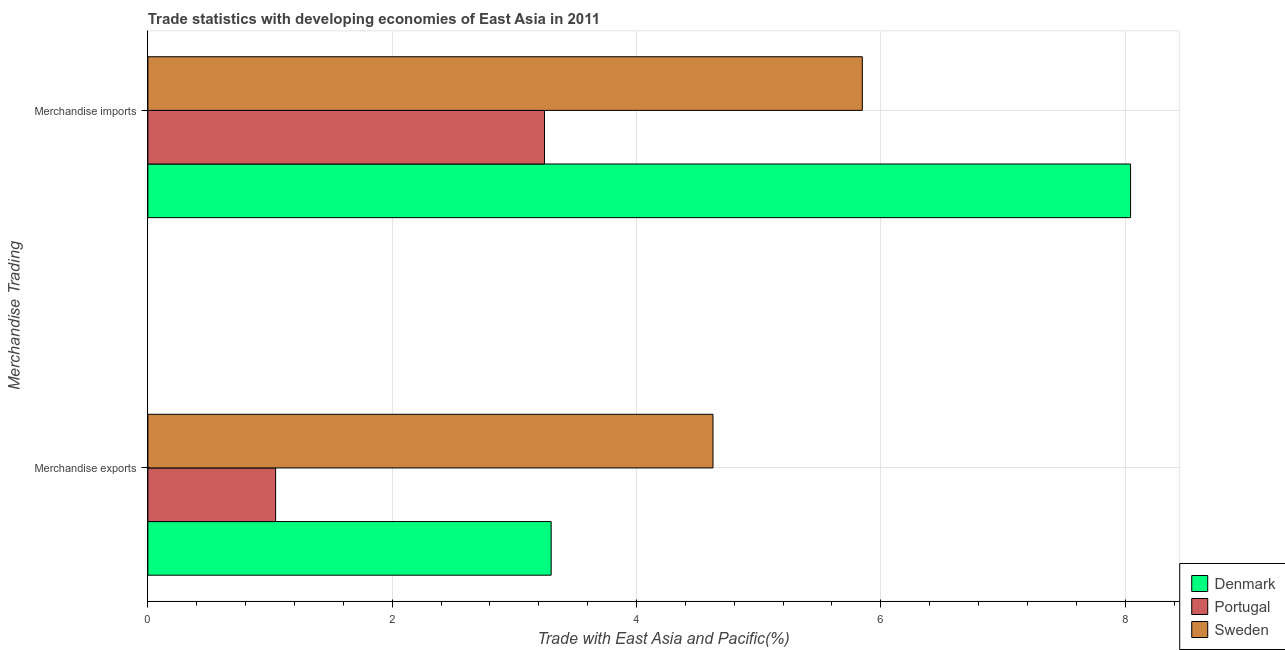Are the number of bars per tick equal to the number of legend labels?
Keep it short and to the point. Yes. Are the number of bars on each tick of the Y-axis equal?
Ensure brevity in your answer.  Yes. How many bars are there on the 2nd tick from the bottom?
Ensure brevity in your answer.  3. What is the merchandise exports in Portugal?
Provide a short and direct response. 1.05. Across all countries, what is the maximum merchandise exports?
Offer a very short reply. 4.63. Across all countries, what is the minimum merchandise exports?
Your answer should be compact. 1.05. In which country was the merchandise exports maximum?
Ensure brevity in your answer.  Sweden. In which country was the merchandise exports minimum?
Give a very brief answer. Portugal. What is the total merchandise exports in the graph?
Ensure brevity in your answer.  8.97. What is the difference between the merchandise imports in Sweden and that in Denmark?
Ensure brevity in your answer.  -2.2. What is the difference between the merchandise exports in Denmark and the merchandise imports in Sweden?
Give a very brief answer. -2.55. What is the average merchandise exports per country?
Provide a succinct answer. 2.99. What is the difference between the merchandise imports and merchandise exports in Portugal?
Your response must be concise. 2.2. In how many countries, is the merchandise exports greater than 3.2 %?
Provide a succinct answer. 2. What is the ratio of the merchandise exports in Denmark to that in Portugal?
Keep it short and to the point. 3.16. Is the merchandise exports in Sweden less than that in Denmark?
Ensure brevity in your answer.  No. What does the 2nd bar from the bottom in Merchandise exports represents?
Your response must be concise. Portugal. How many countries are there in the graph?
Provide a short and direct response. 3. What is the difference between two consecutive major ticks on the X-axis?
Provide a short and direct response. 2. Are the values on the major ticks of X-axis written in scientific E-notation?
Keep it short and to the point. No. What is the title of the graph?
Your answer should be very brief. Trade statistics with developing economies of East Asia in 2011. Does "Austria" appear as one of the legend labels in the graph?
Ensure brevity in your answer.  No. What is the label or title of the X-axis?
Provide a short and direct response. Trade with East Asia and Pacific(%). What is the label or title of the Y-axis?
Provide a succinct answer. Merchandise Trading. What is the Trade with East Asia and Pacific(%) of Denmark in Merchandise exports?
Offer a terse response. 3.3. What is the Trade with East Asia and Pacific(%) in Portugal in Merchandise exports?
Provide a succinct answer. 1.05. What is the Trade with East Asia and Pacific(%) of Sweden in Merchandise exports?
Make the answer very short. 4.63. What is the Trade with East Asia and Pacific(%) of Denmark in Merchandise imports?
Give a very brief answer. 8.04. What is the Trade with East Asia and Pacific(%) of Portugal in Merchandise imports?
Keep it short and to the point. 3.25. What is the Trade with East Asia and Pacific(%) in Sweden in Merchandise imports?
Give a very brief answer. 5.85. Across all Merchandise Trading, what is the maximum Trade with East Asia and Pacific(%) of Denmark?
Give a very brief answer. 8.04. Across all Merchandise Trading, what is the maximum Trade with East Asia and Pacific(%) of Portugal?
Provide a short and direct response. 3.25. Across all Merchandise Trading, what is the maximum Trade with East Asia and Pacific(%) in Sweden?
Your answer should be very brief. 5.85. Across all Merchandise Trading, what is the minimum Trade with East Asia and Pacific(%) of Denmark?
Make the answer very short. 3.3. Across all Merchandise Trading, what is the minimum Trade with East Asia and Pacific(%) of Portugal?
Your answer should be very brief. 1.05. Across all Merchandise Trading, what is the minimum Trade with East Asia and Pacific(%) of Sweden?
Offer a terse response. 4.63. What is the total Trade with East Asia and Pacific(%) in Denmark in the graph?
Your response must be concise. 11.35. What is the total Trade with East Asia and Pacific(%) of Portugal in the graph?
Keep it short and to the point. 4.29. What is the total Trade with East Asia and Pacific(%) in Sweden in the graph?
Your answer should be very brief. 10.47. What is the difference between the Trade with East Asia and Pacific(%) in Denmark in Merchandise exports and that in Merchandise imports?
Provide a succinct answer. -4.74. What is the difference between the Trade with East Asia and Pacific(%) of Portugal in Merchandise exports and that in Merchandise imports?
Your answer should be compact. -2.2. What is the difference between the Trade with East Asia and Pacific(%) of Sweden in Merchandise exports and that in Merchandise imports?
Offer a very short reply. -1.22. What is the difference between the Trade with East Asia and Pacific(%) of Denmark in Merchandise exports and the Trade with East Asia and Pacific(%) of Portugal in Merchandise imports?
Give a very brief answer. 0.05. What is the difference between the Trade with East Asia and Pacific(%) in Denmark in Merchandise exports and the Trade with East Asia and Pacific(%) in Sweden in Merchandise imports?
Your response must be concise. -2.55. What is the difference between the Trade with East Asia and Pacific(%) in Portugal in Merchandise exports and the Trade with East Asia and Pacific(%) in Sweden in Merchandise imports?
Your response must be concise. -4.8. What is the average Trade with East Asia and Pacific(%) in Denmark per Merchandise Trading?
Give a very brief answer. 5.67. What is the average Trade with East Asia and Pacific(%) in Portugal per Merchandise Trading?
Offer a very short reply. 2.15. What is the average Trade with East Asia and Pacific(%) in Sweden per Merchandise Trading?
Your answer should be compact. 5.24. What is the difference between the Trade with East Asia and Pacific(%) in Denmark and Trade with East Asia and Pacific(%) in Portugal in Merchandise exports?
Provide a succinct answer. 2.26. What is the difference between the Trade with East Asia and Pacific(%) in Denmark and Trade with East Asia and Pacific(%) in Sweden in Merchandise exports?
Offer a terse response. -1.32. What is the difference between the Trade with East Asia and Pacific(%) in Portugal and Trade with East Asia and Pacific(%) in Sweden in Merchandise exports?
Your response must be concise. -3.58. What is the difference between the Trade with East Asia and Pacific(%) of Denmark and Trade with East Asia and Pacific(%) of Portugal in Merchandise imports?
Your answer should be very brief. 4.8. What is the difference between the Trade with East Asia and Pacific(%) in Denmark and Trade with East Asia and Pacific(%) in Sweden in Merchandise imports?
Keep it short and to the point. 2.2. What is the difference between the Trade with East Asia and Pacific(%) in Portugal and Trade with East Asia and Pacific(%) in Sweden in Merchandise imports?
Offer a terse response. -2.6. What is the ratio of the Trade with East Asia and Pacific(%) in Denmark in Merchandise exports to that in Merchandise imports?
Offer a very short reply. 0.41. What is the ratio of the Trade with East Asia and Pacific(%) in Portugal in Merchandise exports to that in Merchandise imports?
Offer a terse response. 0.32. What is the ratio of the Trade with East Asia and Pacific(%) of Sweden in Merchandise exports to that in Merchandise imports?
Offer a terse response. 0.79. What is the difference between the highest and the second highest Trade with East Asia and Pacific(%) in Denmark?
Offer a terse response. 4.74. What is the difference between the highest and the second highest Trade with East Asia and Pacific(%) in Portugal?
Your response must be concise. 2.2. What is the difference between the highest and the second highest Trade with East Asia and Pacific(%) of Sweden?
Make the answer very short. 1.22. What is the difference between the highest and the lowest Trade with East Asia and Pacific(%) of Denmark?
Ensure brevity in your answer.  4.74. What is the difference between the highest and the lowest Trade with East Asia and Pacific(%) of Portugal?
Give a very brief answer. 2.2. What is the difference between the highest and the lowest Trade with East Asia and Pacific(%) of Sweden?
Your answer should be compact. 1.22. 